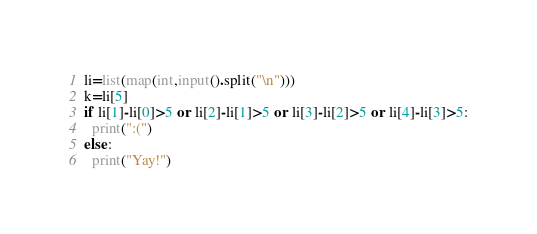<code> <loc_0><loc_0><loc_500><loc_500><_Python_>li=list(map(int,input().split("\n")))
k=li[5]
if li[1]-li[0]>5 or li[2]-li[1]>5 or li[3]-li[2]>5 or li[4]-li[3]>5:
  print(":(")
else:
  print("Yay!")</code> 